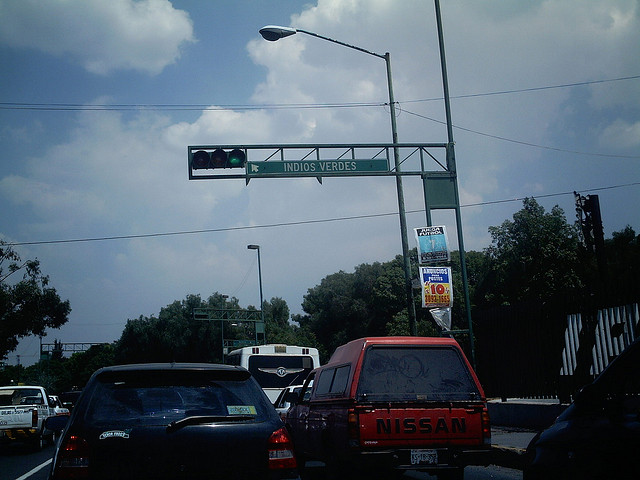Are there any commercial signs or billboards in the picture? Yes, there is a billboard visible to the right of the image, just above the trucks in the scene. It appears to display an advertisement. 